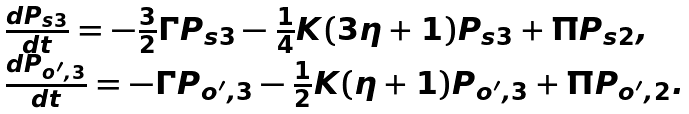Convert formula to latex. <formula><loc_0><loc_0><loc_500><loc_500>\begin{array} { l } \frac { d { P } _ { s 3 } } { d t } = - \frac { 3 } { 2 } \Gamma P _ { s 3 } - \frac { 1 } { 4 } K ( 3 \eta + 1 ) P _ { s 3 } + \Pi P _ { s 2 } , \\ \frac { d { P } _ { o ^ { \prime } , 3 } } { d t } = - \Gamma P _ { o ^ { \prime } , 3 } - \frac { 1 } { 2 } K ( \eta + 1 ) P _ { o ^ { \prime } , 3 } + \Pi P _ { o ^ { \prime } , 2 } . \\ \end{array}</formula> 